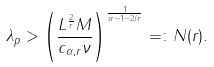Convert formula to latex. <formula><loc_0><loc_0><loc_500><loc_500>\lambda _ { p } > \left ( \frac { L ^ { \frac { 2 } { r } } M } { c _ { \alpha , r } \nu } \right ) ^ { \frac { 1 } { \alpha - 1 - 2 / r } } = \colon N ( r ) .</formula> 